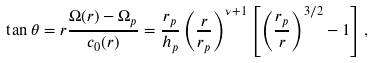<formula> <loc_0><loc_0><loc_500><loc_500>\tan \theta = r \frac { \Omega ( r ) - \Omega _ { p } } { c _ { 0 } ( r ) } = \frac { r _ { p } } { h _ { p } } \left ( \frac { r } { r _ { p } } \right ) ^ { \nu + 1 } \left [ \left ( \frac { r _ { p } } { r } \right ) ^ { 3 / 2 } - 1 \right ] ,</formula> 